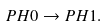<formula> <loc_0><loc_0><loc_500><loc_500>P H 0 \rightarrow P H 1 .</formula> 